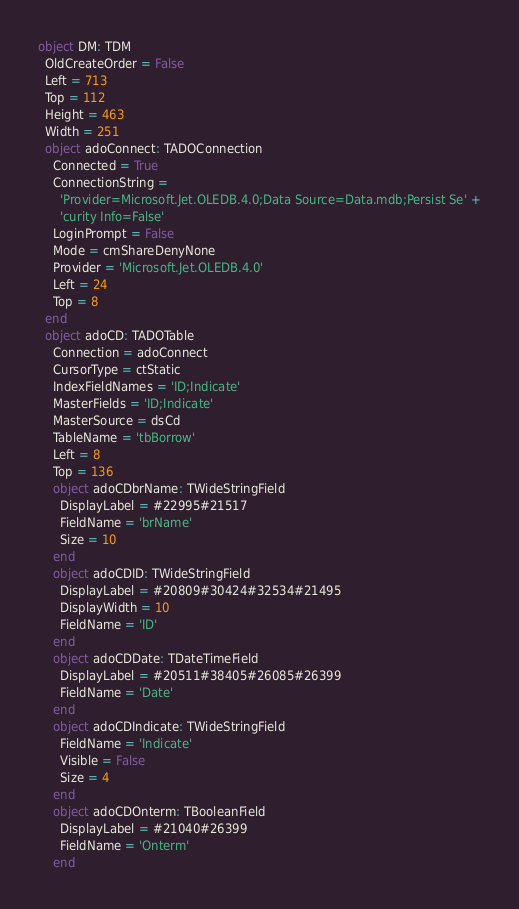<code> <loc_0><loc_0><loc_500><loc_500><_Pascal_>object DM: TDM
  OldCreateOrder = False
  Left = 713
  Top = 112
  Height = 463
  Width = 251
  object adoConnect: TADOConnection
    Connected = True
    ConnectionString = 
      'Provider=Microsoft.Jet.OLEDB.4.0;Data Source=Data.mdb;Persist Se' +
      'curity Info=False'
    LoginPrompt = False
    Mode = cmShareDenyNone
    Provider = 'Microsoft.Jet.OLEDB.4.0'
    Left = 24
    Top = 8
  end
  object adoCD: TADOTable
    Connection = adoConnect
    CursorType = ctStatic
    IndexFieldNames = 'ID;Indicate'
    MasterFields = 'ID;Indicate'
    MasterSource = dsCd
    TableName = 'tbBorrow'
    Left = 8
    Top = 136
    object adoCDbrName: TWideStringField
      DisplayLabel = #22995#21517
      FieldName = 'brName'
      Size = 10
    end
    object adoCDID: TWideStringField
      DisplayLabel = #20809#30424#32534#21495
      DisplayWidth = 10
      FieldName = 'ID'
    end
    object adoCDDate: TDateTimeField
      DisplayLabel = #20511#38405#26085#26399
      FieldName = 'Date'
    end
    object adoCDIndicate: TWideStringField
      FieldName = 'Indicate'
      Visible = False
      Size = 4
    end
    object adoCDOnterm: TBooleanField
      DisplayLabel = #21040#26399
      FieldName = 'Onterm'
    end</code> 